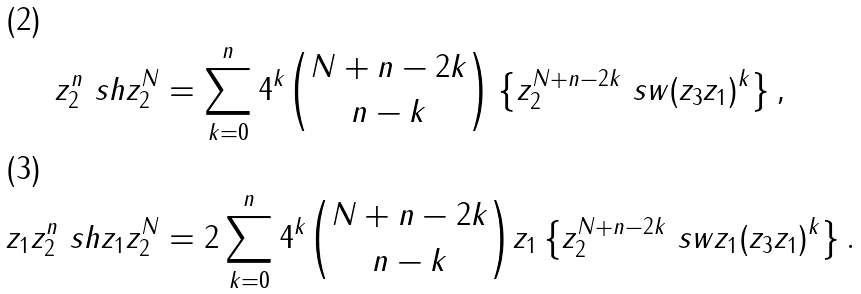Convert formula to latex. <formula><loc_0><loc_0><loc_500><loc_500>z _ { 2 } ^ { n } \ s h z _ { 2 } ^ { N } & = \sum _ { k = 0 } ^ { n } 4 ^ { k } \binom { N + n - 2 k } { n - k } \left \{ z _ { 2 } ^ { N + n - 2 k } \ s w ( z _ { 3 } z _ { 1 } ) ^ { k } \right \} , \\ z _ { 1 } z _ { 2 } ^ { n } \ s h z _ { 1 } z _ { 2 } ^ { N } & = 2 \sum _ { k = 0 } ^ { n } 4 ^ { k } \binom { N + n - 2 k } { n - k } z _ { 1 } \left \{ z _ { 2 } ^ { N + n - 2 k } \ s w z _ { 1 } ( z _ { 3 } z _ { 1 } ) ^ { k } \right \} .</formula> 